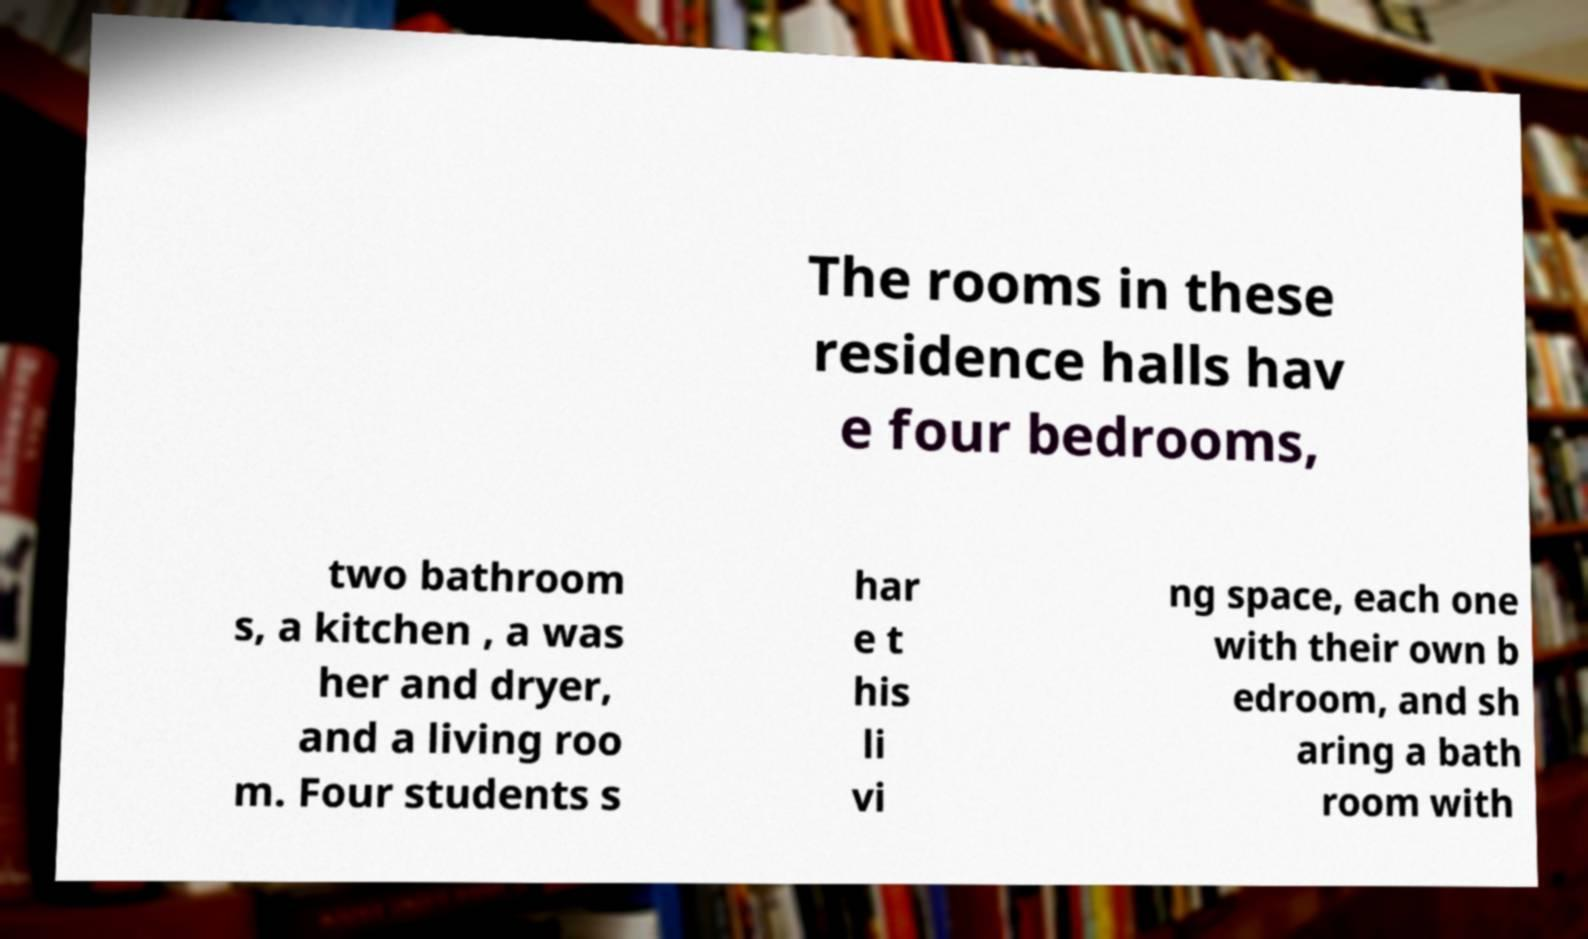Please identify and transcribe the text found in this image. The rooms in these residence halls hav e four bedrooms, two bathroom s, a kitchen , a was her and dryer, and a living roo m. Four students s har e t his li vi ng space, each one with their own b edroom, and sh aring a bath room with 